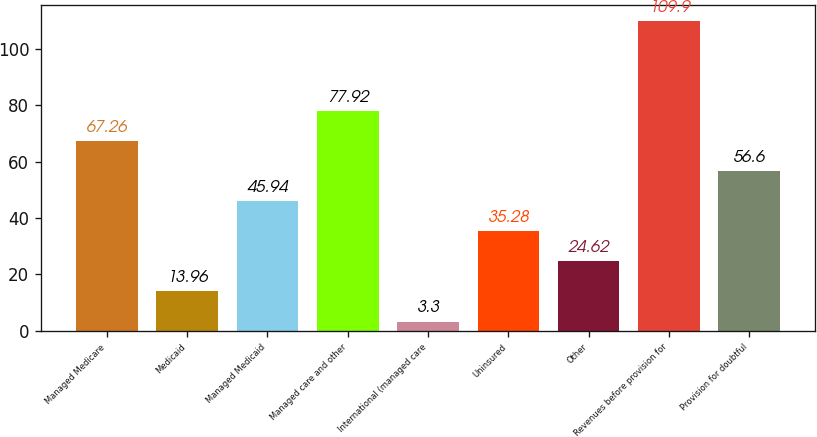Convert chart to OTSL. <chart><loc_0><loc_0><loc_500><loc_500><bar_chart><fcel>Managed Medicare<fcel>Medicaid<fcel>Managed Medicaid<fcel>Managed care and other<fcel>International (managed care<fcel>Uninsured<fcel>Other<fcel>Revenues before provision for<fcel>Provision for doubtful<nl><fcel>67.26<fcel>13.96<fcel>45.94<fcel>77.92<fcel>3.3<fcel>35.28<fcel>24.62<fcel>109.9<fcel>56.6<nl></chart> 